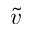<formula> <loc_0><loc_0><loc_500><loc_500>\tilde { v }</formula> 